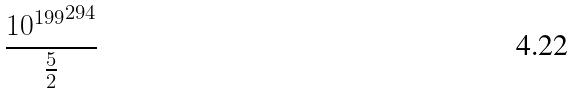<formula> <loc_0><loc_0><loc_500><loc_500>\frac { { 1 0 ^ { 1 9 9 } } ^ { 2 9 4 } } { \frac { 5 } { 2 } }</formula> 